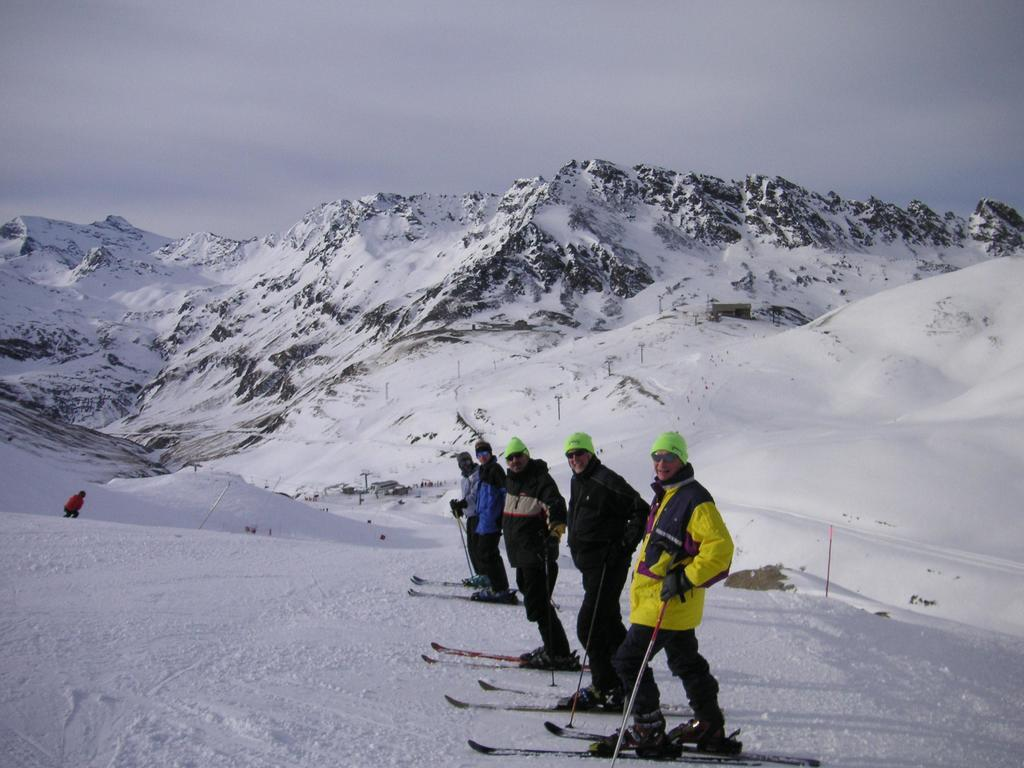How many people are in the image? There are five members in the image. What are the members doing in the image? The members are on skiing boards. What type of terrain is visible in the image? There is snow visible in the image, and hills can be seen in the background. What is visible in the sky in the image? The sky is visible in the background of the image. What type of peace symbol can be seen on the skiing boards? There is no peace symbol present on the skiing boards in the image. How many ants can be seen crawling on the snow in the image? There are no ants present in the image; it features people skiing on snow. 